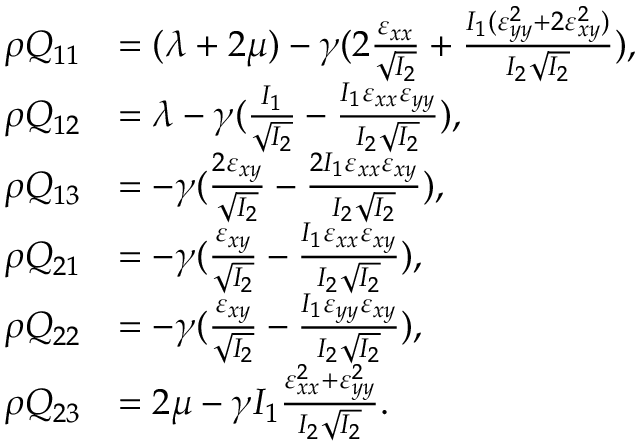Convert formula to latex. <formula><loc_0><loc_0><loc_500><loc_500>\begin{array} { r l } { \rho Q _ { 1 1 } } & { = ( \lambda + 2 \mu ) - \gamma ( 2 \frac { \varepsilon _ { x x } } { \sqrt { I _ { 2 } } } + \frac { I _ { 1 } ( \varepsilon _ { y y } ^ { 2 } + 2 \varepsilon _ { x y } ^ { 2 } ) } { I _ { 2 } \sqrt { I _ { 2 } } } ) , } \\ { \rho Q _ { 1 2 } } & { = \lambda - \gamma ( \frac { I _ { 1 } } { \sqrt { I _ { 2 } } } - \frac { I _ { 1 } \varepsilon _ { x x } \varepsilon _ { y y } } { I _ { 2 } \sqrt { I _ { 2 } } } ) , } \\ { \rho Q _ { 1 3 } } & { = - \gamma ( \frac { 2 \varepsilon _ { x y } } { \sqrt { I _ { 2 } } } - \frac { 2 I _ { 1 } \varepsilon _ { x x } \varepsilon _ { x y } } { I _ { 2 } \sqrt { I _ { 2 } } } ) , } \\ { \rho Q _ { 2 1 } } & { = - \gamma ( \frac { \varepsilon _ { x y } } { \sqrt { I _ { 2 } } } - \frac { I _ { 1 } \varepsilon _ { x x } \varepsilon _ { x y } } { I _ { 2 } \sqrt { I _ { 2 } } } ) , } \\ { \rho Q _ { 2 2 } } & { = - \gamma ( \frac { \varepsilon _ { x y } } { \sqrt { I _ { 2 } } } - \frac { I _ { 1 } \varepsilon _ { y y } \varepsilon _ { x y } } { I _ { 2 } \sqrt { I _ { 2 } } } ) , } \\ { \rho Q _ { 2 3 } } & { = 2 \mu - \gamma I _ { 1 } \frac { \varepsilon _ { x x } ^ { 2 } + \varepsilon _ { y y } ^ { 2 } } { I _ { 2 } \sqrt { I _ { 2 } } } . } \end{array}</formula> 